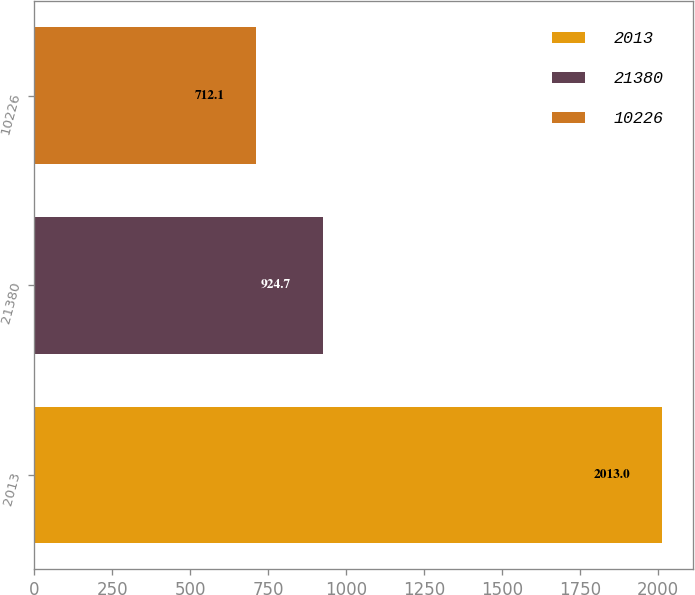Convert chart. <chart><loc_0><loc_0><loc_500><loc_500><bar_chart><fcel>2013<fcel>21380<fcel>10226<nl><fcel>2013<fcel>924.7<fcel>712.1<nl></chart> 